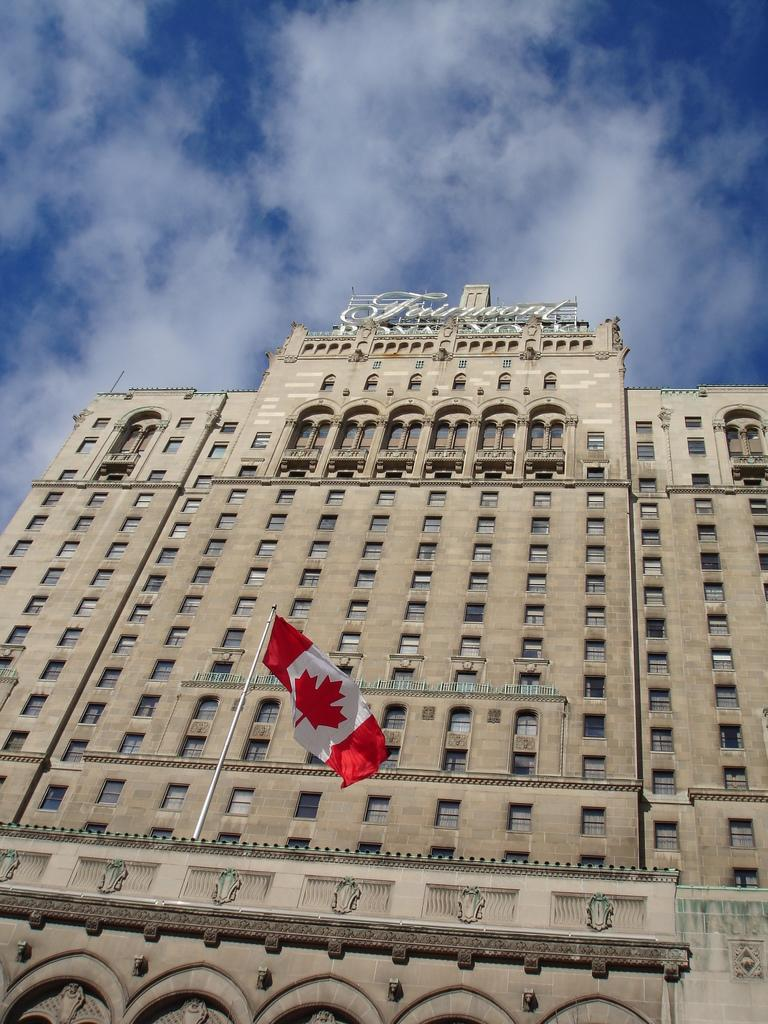What structure is the main subject of the image? There is a building in the image. What can be seen at the top of the building? There is text at the top of the building. What architectural feature is present on the building? There are windows on the building. What is attached to the building? There is a flag on the building. What is visible in the background of the image? The sky is visible in the background of the image. What can be observed in the sky? Clouds are present in the sky. Can you tell me how many squirrels are climbing on the building in the image? There are no squirrels present in the image; it features a building with text, windows, a flag, and a sky with clouds. What type of rifle is being used by the person standing next to the building in the image? There is no person or rifle present in the image; it only features a building, text, windows, a flag, and a sky with clouds. 